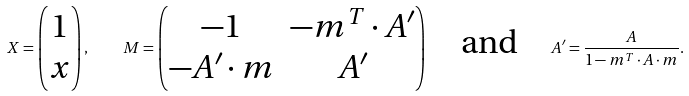<formula> <loc_0><loc_0><loc_500><loc_500>X = \begin{pmatrix} 1 \\ x \end{pmatrix} , \quad M = \begin{pmatrix} - 1 & - m ^ { T } \cdot A ^ { \prime } \\ - A ^ { \prime } \cdot m & A ^ { \prime } \end{pmatrix} \quad \text {and} \quad A ^ { \prime } = \frac { A } { 1 - m ^ { T } \cdot A \cdot m } .</formula> 